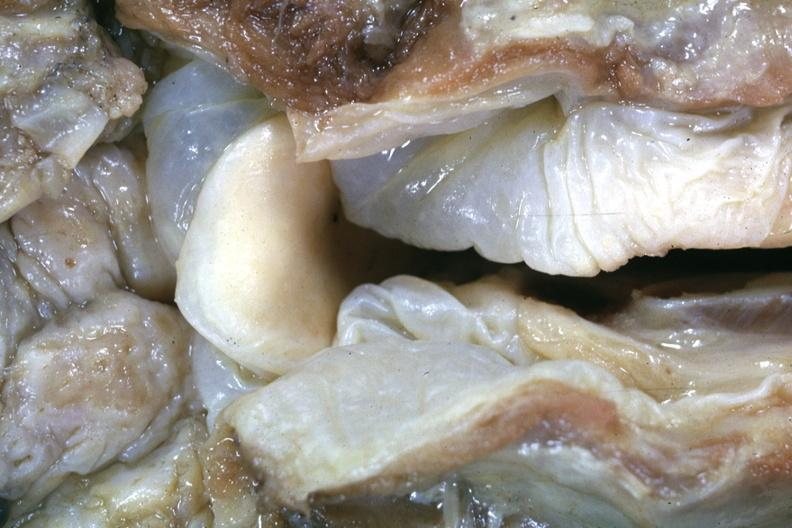where is this?
Answer the question using a single word or phrase. Oral 